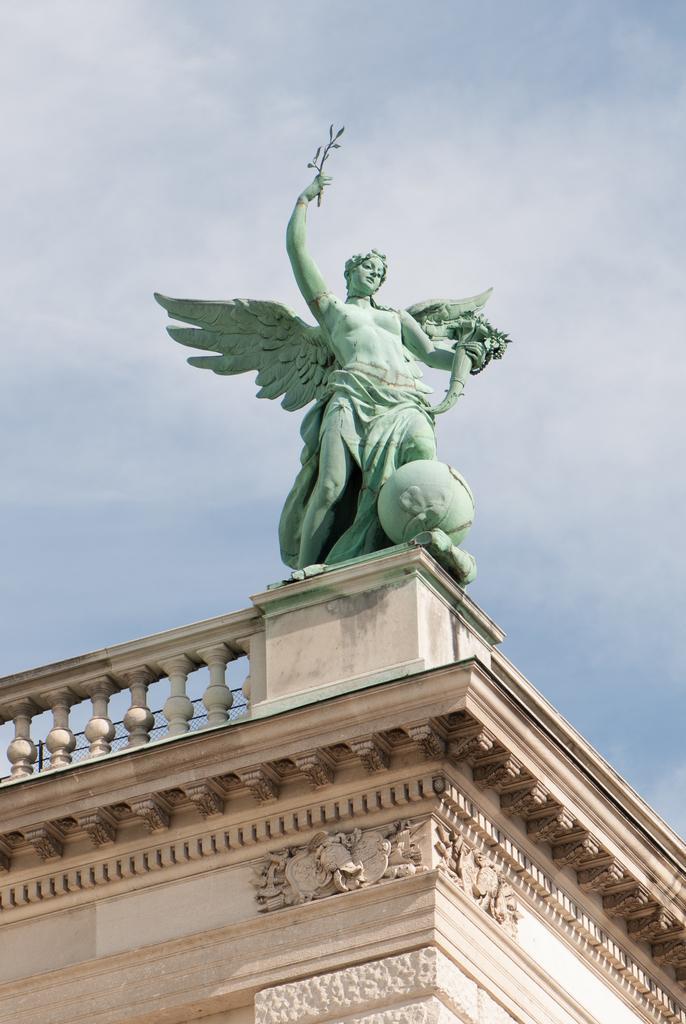Describe this image in one or two sentences. In this picture there is a blue color statue which is above the building. Here we can see a concrete fencing. On the background we can see sky and clouds. 